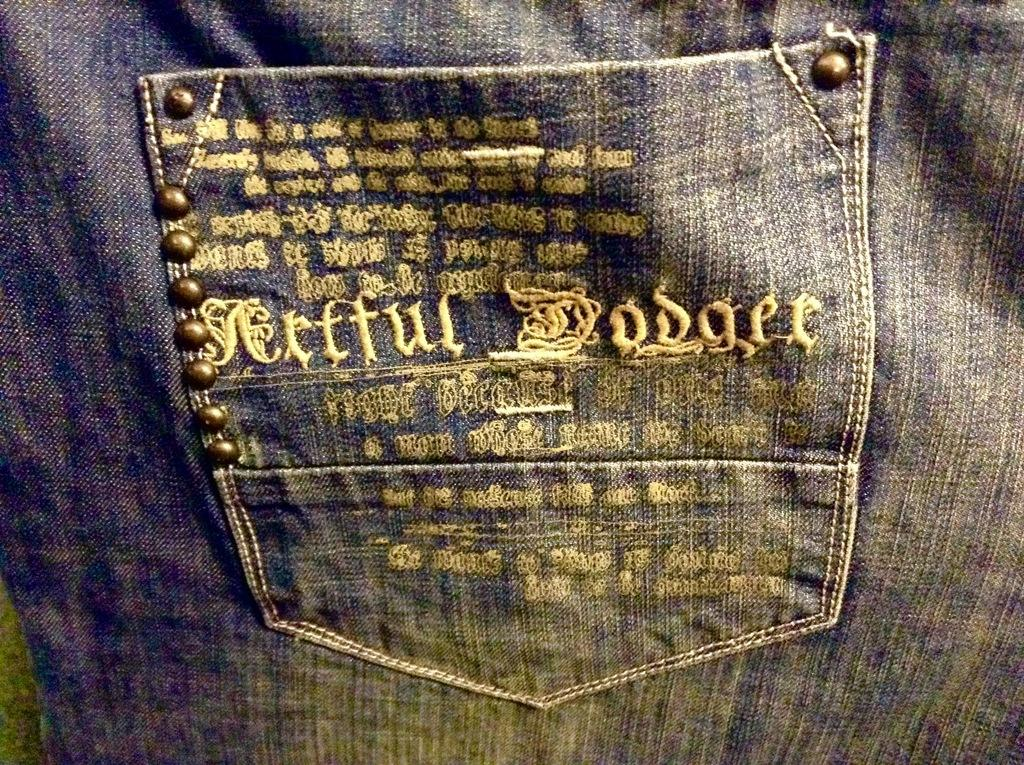What type of clothing item is featured in the image? There is a pair of jeans in the image. What part of the jeans is visible in the image? The pocket of the jeans is visible in the image. What is written or depicted on the pocket? There is some text on the pocket. Are there any additional features on the pocket? Yes, there are buttons on the pocket. What type of feast is being prepared in the image? There is no feast or any indication of food preparation in the image; it features a pocket on a pair of jeans. How many ears are visible in the image? There are no ears visible in the image; it features a pocket on a pair of jeans. 